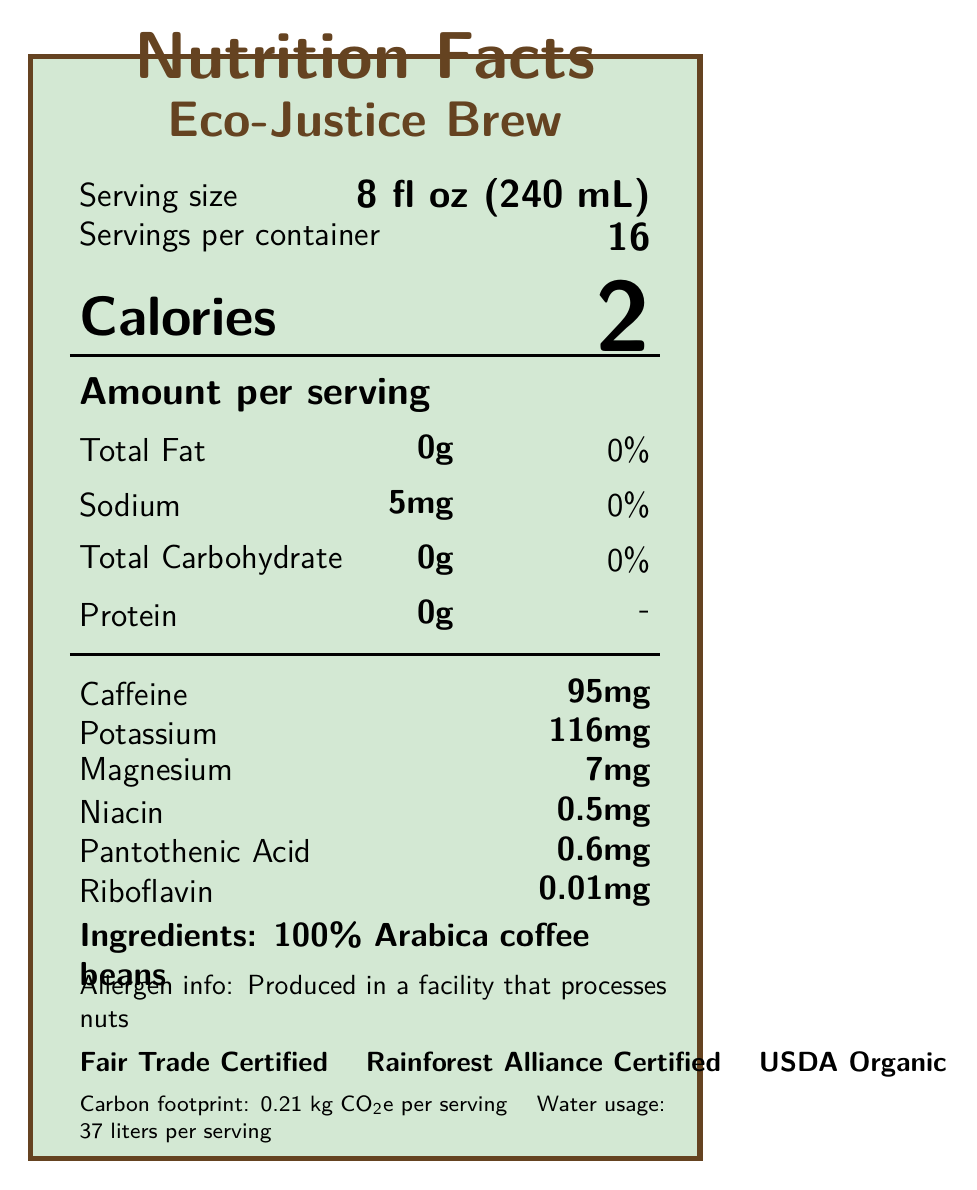what is the serving size? The document mentions the serving size as 8 fl oz (240 mL) under the "Serving information" section.
Answer: 8 fl oz (240 mL) how many servings are in one container? The document specifies that there are 16 servings per container, also found in the "Serving information" section.
Answer: 16 what is the calorie count per serving? Located in the "Calorie information" section, the document states that each serving contains 2 calories.
Answer: 2 calories which type of coffee beans are used in this product? The "Ingredients" section lists 100% Arabica coffee beans as the sole ingredient.
Answer: 100% Arabica coffee beans what certifications does this coffee have? These certifications are listed toward the bottom of the document under "Certifications".
Answer: Fair Trade Certified, Rainforest Alliance Certified, USDA Organic how much sodium does one serving contain? A. 0mg B. 5mg C. 10mg D. 20mg The document indicates that one serving contains 5mg of sodium.
Answer: B what is the caffeine content per serving? A. 50mg B. 75mg C. 95mg D. 120mg The document mentions that each serving contains 95mg of caffeine.
Answer: C is this product produced in a facility that processes nuts? The document contains a note in the "Allergen info" section stating that the product is produced in a facility that processes nuts.
Answer: Yes does the coffee have recyclable packaging? The "Environmental impact" section mentions that the packaging is 100% recyclable and compostable.
Answer: Yes describe the main idea of this document The document not only lists the nutritional facts but also elaborates on the ethical and environmental impact of the coffee, emphasizing its sustainability and ethical labor practices.
Answer: The document provides detailed nutritional information along with environmental, ethical certifications, and worker conditions for "Eco-Justice Brew" coffee by Rainforest Alliance Certified Coffee Co. It highlights the product's key features including low calorie count, specific nutrient content, and comprehensive sustainability initiatives. what is the worker minimum wage compared to the local living wage? The "worker conditions" section states that the minimum wage is 150% of the local living wage.
Answer: 150% of the local living wage how is this coffee's roast level described? The roast level for the coffee is specified as medium-dark in the document.
Answer: Medium-dark what specific programs are included in the company's sustainability initiatives? The "sustainability initiatives" section lists these specific programs.
Answer: Reforestation program, Solar-powered roasting facility, Farmer training on sustainable agriculture practices what is the carbon footprint per serving of this coffee? The "Environmental impact" section specifies the carbon footprint as 0.21 kg CO2e per serving.
Answer: 0.21 kg CO2e per serving how many liters of water are used per serving of this coffee? The "Environmental impact" section also mentions that 37 liters of water are used per serving.
Answer: 37 liters where is this coffee grown? A. Brazil B. Colombia C. Ethiopia D. Vietnam The "origin" section specifies that the coffee is grown in Colombia, in the Sierra Nevada de Santa Marta region.
Answer: B what is the flavor profile of this coffee? The "flavor profile" section lists these notes as part of the coffee's flavor.
Answer: Dark chocolate, Caramel, Citrus does the document mention anything about worker conditions? The "worker conditions" section includes details on wages, working hours, child labor, health benefits, and education support.
Answer: Yes is there any information on the profit-sharing model in this document? The document mentions that 10% of profits are reinvested in farming communities under the "social impact" section.
Answer: Yes can the exact cost of the coffee be determined from this document? The document does not provide any pricing details for the coffee.
Answer: Not enough information 